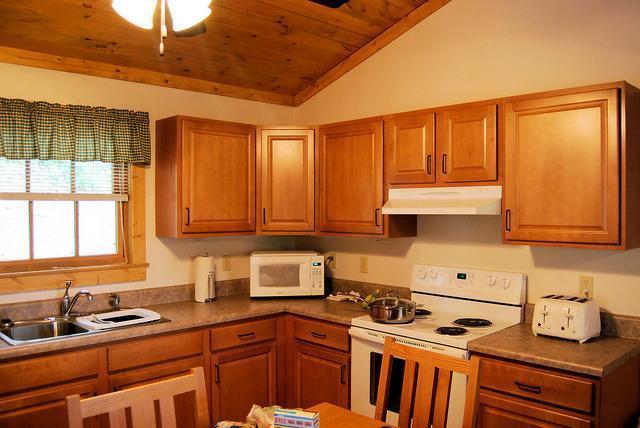How many chairs are visible?
Give a very brief answer. 2. How many woman are holding a donut with one hand?
Give a very brief answer. 0. 